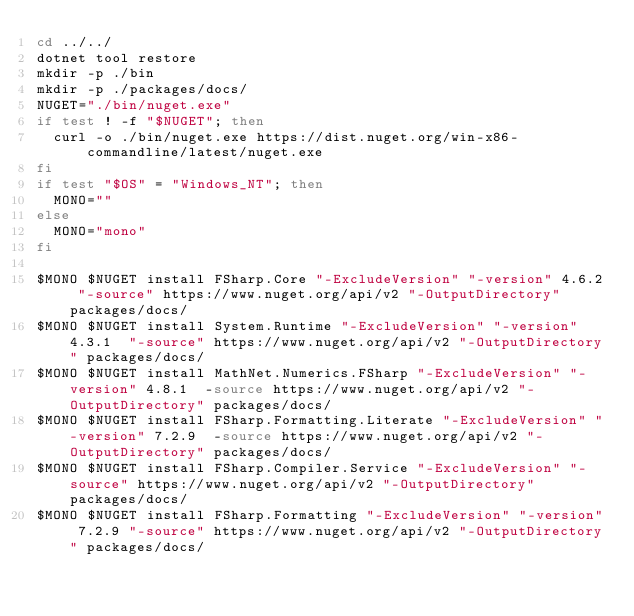Convert code to text. <code><loc_0><loc_0><loc_500><loc_500><_Bash_>cd ../../
dotnet tool restore
mkdir -p ./bin
mkdir -p ./packages/docs/
NUGET="./bin/nuget.exe"
if test ! -f "$NUGET"; then
  curl -o ./bin/nuget.exe https://dist.nuget.org/win-x86-commandline/latest/nuget.exe
fi
if test "$OS" = "Windows_NT"; then
  MONO=""
else
  MONO="mono"
fi

$MONO $NUGET install FSharp.Core "-ExcludeVersion" "-version" 4.6.2 "-source" https://www.nuget.org/api/v2 "-OutputDirectory" packages/docs/
$MONO $NUGET install System.Runtime "-ExcludeVersion" "-version" 4.3.1  "-source" https://www.nuget.org/api/v2 "-OutputDirectory" packages/docs/
$MONO $NUGET install MathNet.Numerics.FSharp "-ExcludeVersion" "-version" 4.8.1  -source https://www.nuget.org/api/v2 "-OutputDirectory" packages/docs/
$MONO $NUGET install FSharp.Formatting.Literate "-ExcludeVersion" "-version" 7.2.9  -source https://www.nuget.org/api/v2 "-OutputDirectory" packages/docs/
$MONO $NUGET install FSharp.Compiler.Service "-ExcludeVersion" "-source" https://www.nuget.org/api/v2 "-OutputDirectory" packages/docs/
$MONO $NUGET install FSharp.Formatting "-ExcludeVersion" "-version" 7.2.9 "-source" https://www.nuget.org/api/v2 "-OutputDirectory" packages/docs/
</code> 